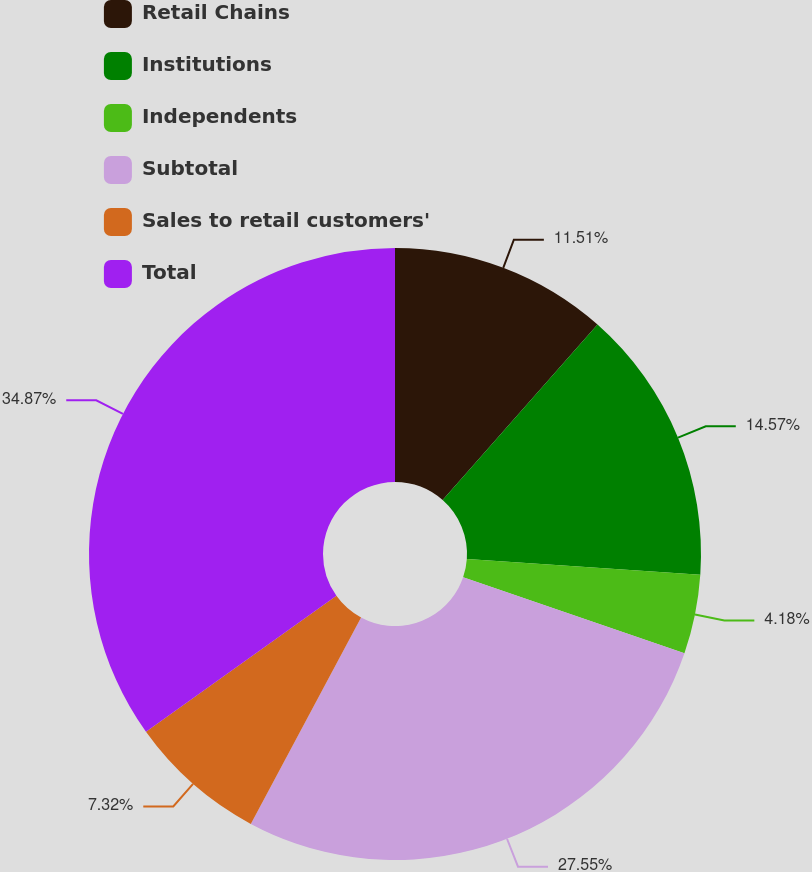Convert chart to OTSL. <chart><loc_0><loc_0><loc_500><loc_500><pie_chart><fcel>Retail Chains<fcel>Institutions<fcel>Independents<fcel>Subtotal<fcel>Sales to retail customers'<fcel>Total<nl><fcel>11.51%<fcel>14.57%<fcel>4.18%<fcel>27.55%<fcel>7.32%<fcel>34.87%<nl></chart> 